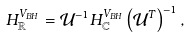<formula> <loc_0><loc_0><loc_500><loc_500>H _ { \mathbb { R } } ^ { V _ { B H } } = \mathcal { U } ^ { - 1 } H _ { \mathbb { C } } ^ { V _ { B H } } \left ( \mathcal { U } ^ { T } \right ) ^ { - 1 } ,</formula> 